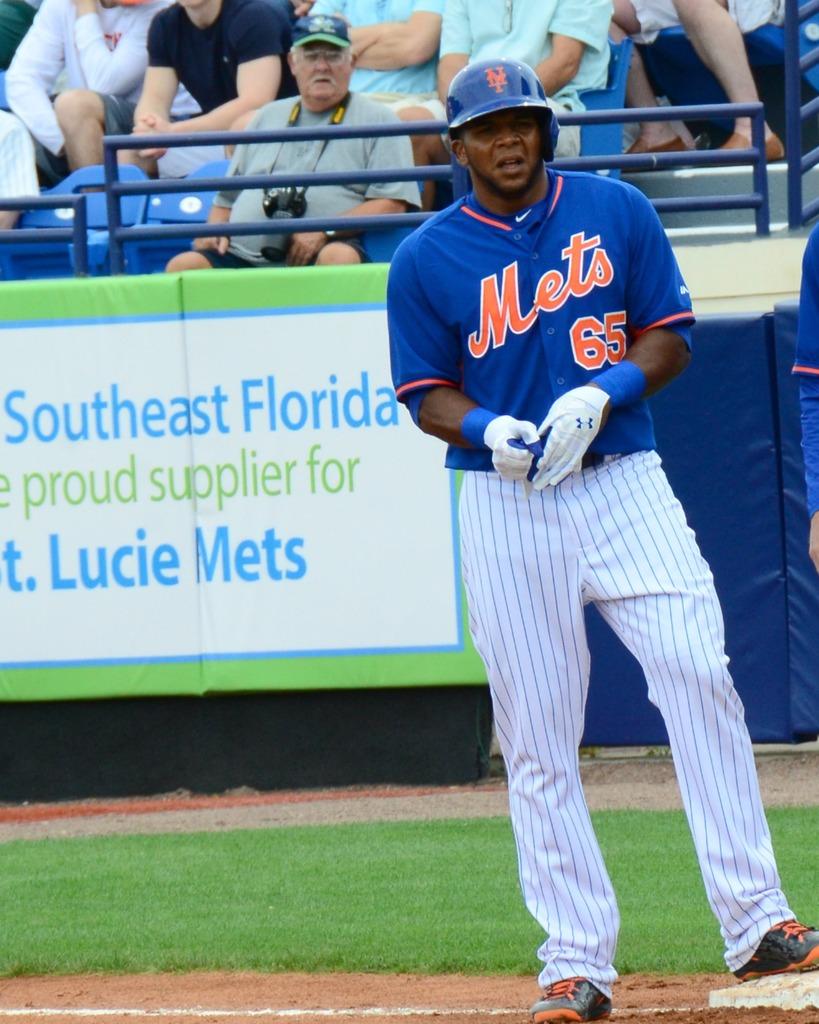Who is one of their suppliers?
Ensure brevity in your answer.  Southeast florida. What team is on the jersey?
Provide a short and direct response. Mets. 